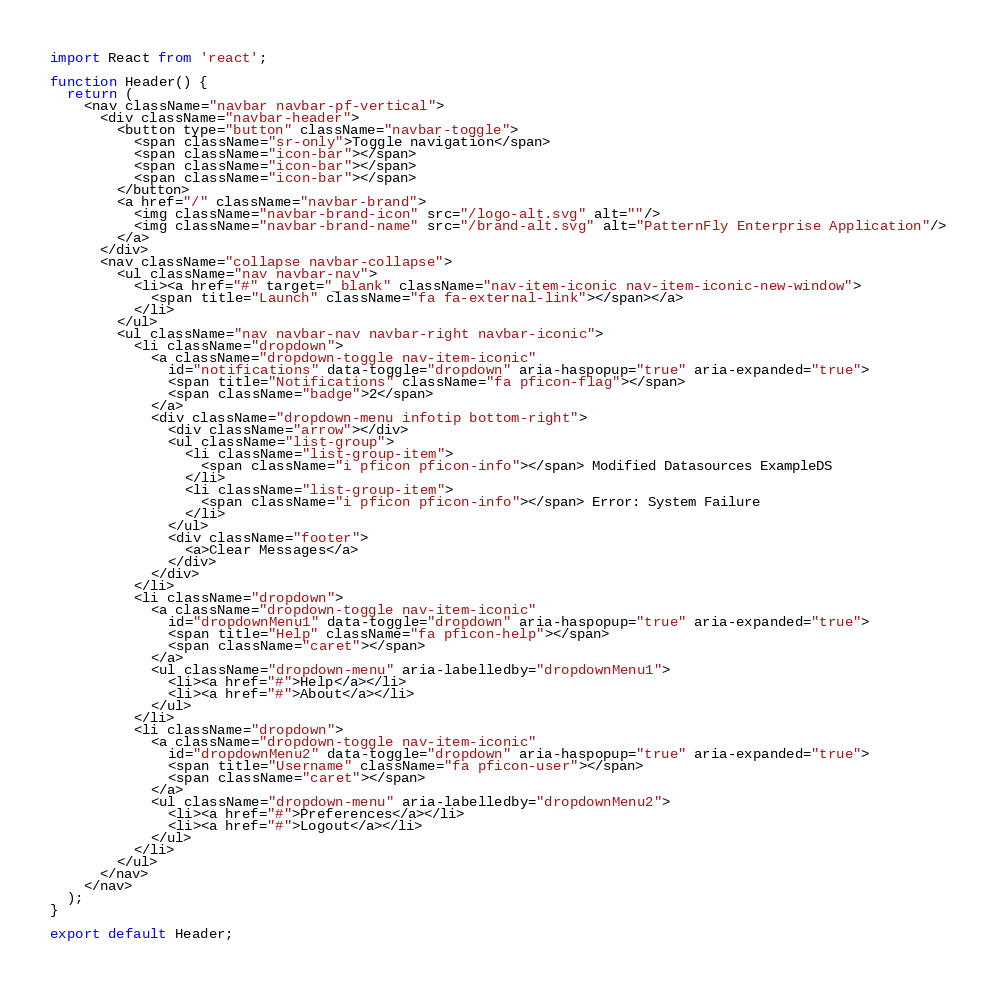<code> <loc_0><loc_0><loc_500><loc_500><_JavaScript_>import React from 'react';

function Header() {
  return (
    <nav className="navbar navbar-pf-vertical">
      <div className="navbar-header">
        <button type="button" className="navbar-toggle">
          <span className="sr-only">Toggle navigation</span>
          <span className="icon-bar"></span>
          <span className="icon-bar"></span>
          <span className="icon-bar"></span>
        </button>
        <a href="/" className="navbar-brand">
          <img className="navbar-brand-icon" src="/logo-alt.svg" alt=""/>
          <img className="navbar-brand-name" src="/brand-alt.svg" alt="PatternFly Enterprise Application"/>
        </a>
      </div>
      <nav className="collapse navbar-collapse">
        <ul className="nav navbar-nav">
          <li><a href="#" target="_blank" className="nav-item-iconic nav-item-iconic-new-window">
            <span title="Launch" className="fa fa-external-link"></span></a>
          </li>
        </ul>
        <ul className="nav navbar-nav navbar-right navbar-iconic">
          <li className="dropdown">
            <a className="dropdown-toggle nav-item-iconic"
              id="notifications" data-toggle="dropdown" aria-haspopup="true" aria-expanded="true">
              <span title="Notifications" className="fa pficon-flag"></span>
              <span className="badge">2</span>
            </a>
            <div className="dropdown-menu infotip bottom-right">
              <div className="arrow"></div>
              <ul className="list-group">
                <li className="list-group-item">
                  <span className="i pficon pficon-info"></span> Modified Datasources ExampleDS
                </li>
                <li className="list-group-item">
                  <span className="i pficon pficon-info"></span> Error: System Failure
                </li>
              </ul>
              <div className="footer">
                <a>Clear Messages</a>
              </div>
            </div>
          </li>
          <li className="dropdown">
            <a className="dropdown-toggle nav-item-iconic"
              id="dropdownMenu1" data-toggle="dropdown" aria-haspopup="true" aria-expanded="true">
              <span title="Help" className="fa pficon-help"></span>
              <span className="caret"></span>
            </a>
            <ul className="dropdown-menu" aria-labelledby="dropdownMenu1">
              <li><a href="#">Help</a></li>
              <li><a href="#">About</a></li>
            </ul>
          </li>
          <li className="dropdown">
            <a className="dropdown-toggle nav-item-iconic"
              id="dropdownMenu2" data-toggle="dropdown" aria-haspopup="true" aria-expanded="true">
              <span title="Username" className="fa pficon-user"></span>
              <span className="caret"></span>
            </a>
            <ul className="dropdown-menu" aria-labelledby="dropdownMenu2">
              <li><a href="#">Preferences</a></li>
              <li><a href="#">Logout</a></li>
            </ul>
          </li>
        </ul>
      </nav>
    </nav>
  );
}

export default Header;
</code> 